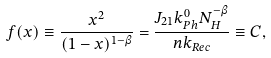Convert formula to latex. <formula><loc_0><loc_0><loc_500><loc_500>f ( x ) \equiv \frac { x ^ { 2 } } { ( 1 - x ) ^ { 1 - \beta } } = \frac { J _ { 2 1 } k _ { P h } ^ { 0 } N _ { H } ^ { - \beta } } { n k _ { R e c } } \equiv C ,</formula> 